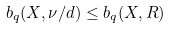<formula> <loc_0><loc_0><loc_500><loc_500>b _ { q } ( X , \nu / d ) \leq b _ { q } ( X , R )</formula> 